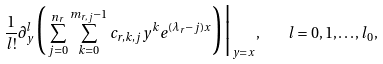<formula> <loc_0><loc_0><loc_500><loc_500>\frac { 1 } { l ! } \partial _ { y } ^ { l } \Big ( \sum _ { j = 0 } ^ { n _ { r } } \sum _ { k = 0 } ^ { m _ { r , j } - 1 } c _ { r , k , j } y ^ { k } e ^ { ( \lambda _ { r } - j ) x } \Big ) \Big | _ { y = x } , \quad l = 0 , 1 , \dots , l _ { 0 } ,</formula> 